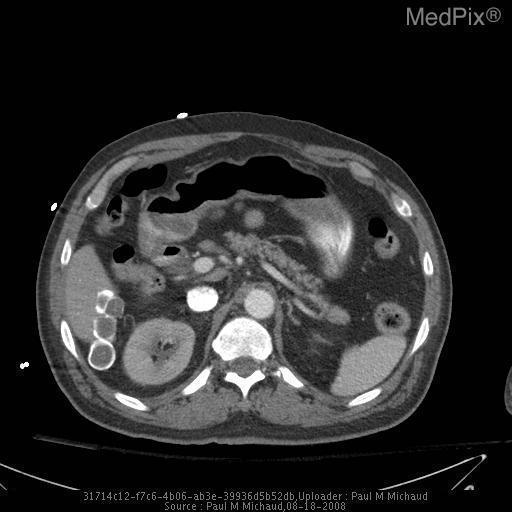How many gallstones are identified?
Concise answer only. 4. Are there gallstones?
Short answer required. Yes. Are gallstones present?
Keep it brief. Yes. What abnormalities are in the right upper quadrant?
Write a very short answer. Gallstones. What is in the right upper quadrant?
Give a very brief answer. Gallstones. Did the patient have a cholecystectomy?
Write a very short answer. Yes. Has the gallbladder been removed?
Keep it brief. Yes. 